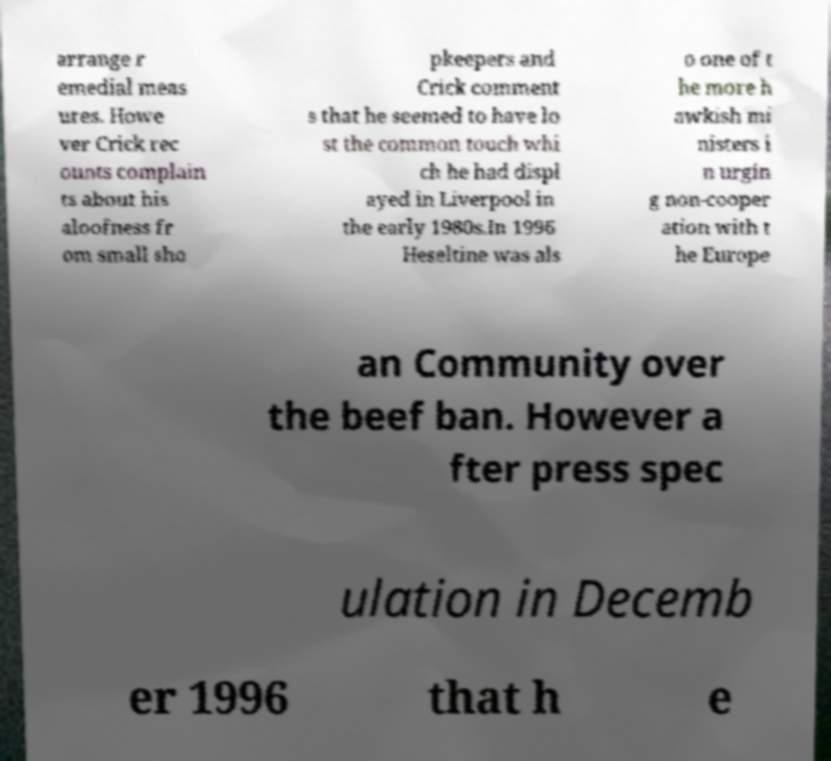Please read and relay the text visible in this image. What does it say? arrange r emedial meas ures. Howe ver Crick rec ounts complain ts about his aloofness fr om small sho pkeepers and Crick comment s that he seemed to have lo st the common touch whi ch he had displ ayed in Liverpool in the early 1980s.In 1996 Heseltine was als o one of t he more h awkish mi nisters i n urgin g non-cooper ation with t he Europe an Community over the beef ban. However a fter press spec ulation in Decemb er 1996 that h e 